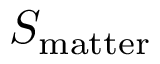Convert formula to latex. <formula><loc_0><loc_0><loc_500><loc_500>S _ { m a t t e r }</formula> 